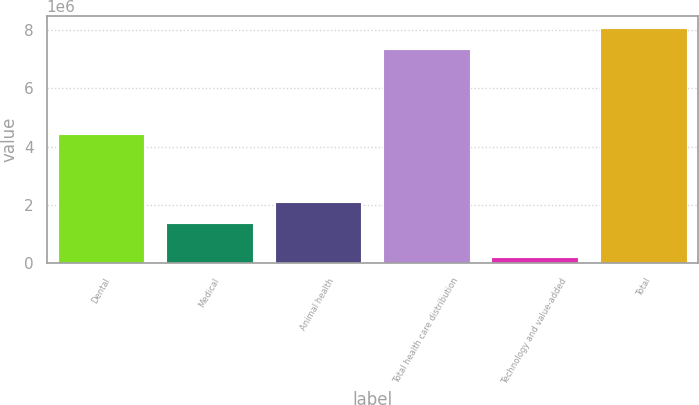Convert chart to OTSL. <chart><loc_0><loc_0><loc_500><loc_500><bar_chart><fcel>Dental<fcel>Medical<fcel>Animal health<fcel>Total health care distribution<fcel>Technology and value-added<fcel>Total<nl><fcel>4.41547e+06<fcel>1.374e+06<fcel>2.10668e+06<fcel>7.32684e+06<fcel>199952<fcel>8.05952e+06<nl></chart> 